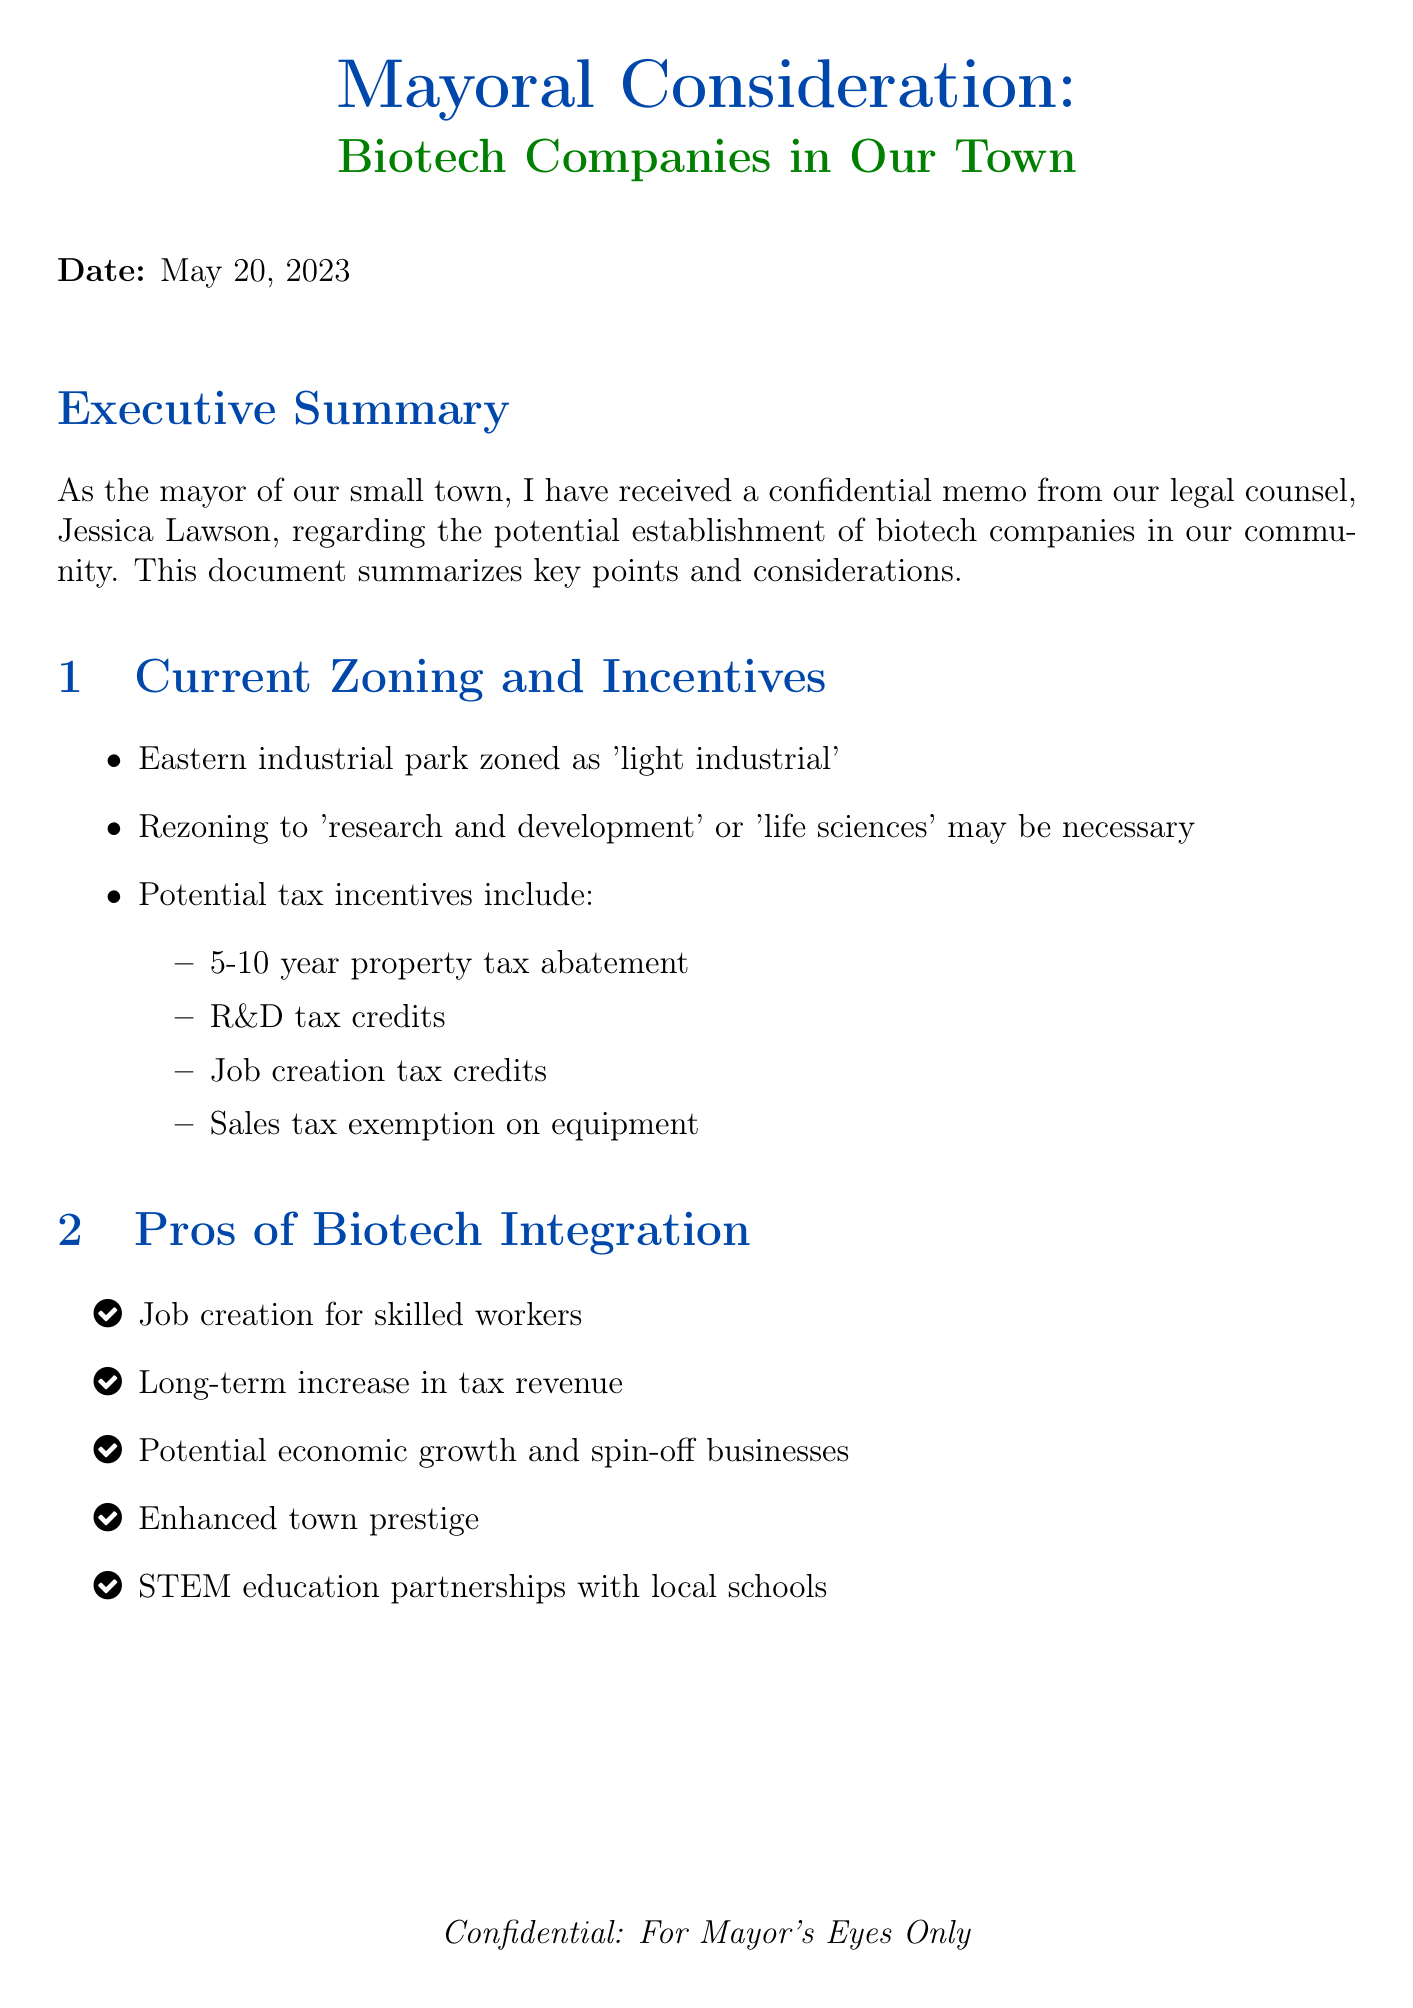What is the date of the memo? The date of the memo is stated clearly in the document as May 15, 2023.
Answer: May 15, 2023 Who is the author of the memo? The author of the memo is Jessica Lawson, who is identified as the Town Legal Counsel.
Answer: Jessica Lawson What are the potential tax incentives mentioned? The document lists multiple tax incentives, including property tax abatement, R&D tax credits, job creation tax credits, and sales tax exemption.
Answer: Property tax abatement, R&D tax credits, job creation tax credits, sales tax exemption What is one pro of attracting biotech companies? The document lists several pros, including job creation, increased tax revenue, potential economic growth, enhanced prestige, and partnerships for STEM education.
Answer: Job creation for skilled workers What is one con of attracting biotech companies? The document outlines several cons, such as initial loss of tax revenue, potential environmental concerns, increased traffic, community resistance, and relocation risks.
Answer: Initial loss of tax revenue What is the suggested next step regarding public input? The document recommends conducting town hall meetings to gather public opinion.
Answer: Conduct town hall meetings Which policy option involves minimal incentives? The document mentions "Cautious Integration" as the policy option focused on minimal incentives and strict zoning.
Answer: Cautious Integration What is an example of a successful biotech hub mentioned? The document provides Kendall Square, Cambridge, MA as a case study of a successful biotech hub.
Answer: Kendall Square, Cambridge, MA What is emphasized as a risk associated with biotech companies? The document emphasizes potential environmental concerns related to chemical storage and waste disposal as a significant risk.
Answer: Potential environmental concerns 